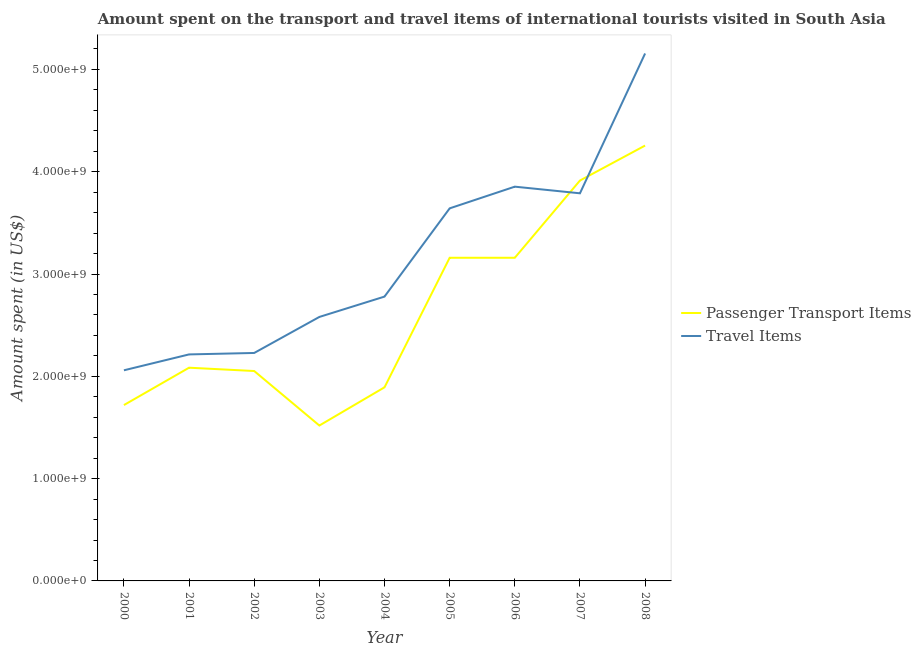Does the line corresponding to amount spent on passenger transport items intersect with the line corresponding to amount spent in travel items?
Make the answer very short. Yes. Is the number of lines equal to the number of legend labels?
Provide a short and direct response. Yes. What is the amount spent in travel items in 2008?
Provide a succinct answer. 5.16e+09. Across all years, what is the maximum amount spent in travel items?
Provide a succinct answer. 5.16e+09. Across all years, what is the minimum amount spent in travel items?
Offer a terse response. 2.06e+09. In which year was the amount spent in travel items minimum?
Keep it short and to the point. 2000. What is the total amount spent on passenger transport items in the graph?
Your answer should be very brief. 2.38e+1. What is the difference between the amount spent on passenger transport items in 2005 and that in 2008?
Offer a very short reply. -1.10e+09. What is the difference between the amount spent on passenger transport items in 2006 and the amount spent in travel items in 2008?
Ensure brevity in your answer.  -2.00e+09. What is the average amount spent in travel items per year?
Provide a succinct answer. 3.14e+09. In the year 2004, what is the difference between the amount spent in travel items and amount spent on passenger transport items?
Offer a terse response. 8.87e+08. In how many years, is the amount spent on passenger transport items greater than 1000000000 US$?
Give a very brief answer. 9. What is the ratio of the amount spent on passenger transport items in 2001 to that in 2006?
Ensure brevity in your answer.  0.66. What is the difference between the highest and the second highest amount spent in travel items?
Provide a succinct answer. 1.30e+09. What is the difference between the highest and the lowest amount spent on passenger transport items?
Provide a short and direct response. 2.74e+09. In how many years, is the amount spent on passenger transport items greater than the average amount spent on passenger transport items taken over all years?
Provide a succinct answer. 4. Is the sum of the amount spent on passenger transport items in 2001 and 2008 greater than the maximum amount spent in travel items across all years?
Provide a succinct answer. Yes. Is the amount spent on passenger transport items strictly greater than the amount spent in travel items over the years?
Ensure brevity in your answer.  No. How many lines are there?
Your answer should be compact. 2. Where does the legend appear in the graph?
Offer a terse response. Center right. What is the title of the graph?
Provide a short and direct response. Amount spent on the transport and travel items of international tourists visited in South Asia. What is the label or title of the X-axis?
Provide a short and direct response. Year. What is the label or title of the Y-axis?
Give a very brief answer. Amount spent (in US$). What is the Amount spent (in US$) in Passenger Transport Items in 2000?
Give a very brief answer. 1.72e+09. What is the Amount spent (in US$) of Travel Items in 2000?
Make the answer very short. 2.06e+09. What is the Amount spent (in US$) in Passenger Transport Items in 2001?
Give a very brief answer. 2.08e+09. What is the Amount spent (in US$) in Travel Items in 2001?
Make the answer very short. 2.21e+09. What is the Amount spent (in US$) of Passenger Transport Items in 2002?
Your response must be concise. 2.05e+09. What is the Amount spent (in US$) of Travel Items in 2002?
Your response must be concise. 2.23e+09. What is the Amount spent (in US$) of Passenger Transport Items in 2003?
Ensure brevity in your answer.  1.52e+09. What is the Amount spent (in US$) in Travel Items in 2003?
Make the answer very short. 2.58e+09. What is the Amount spent (in US$) in Passenger Transport Items in 2004?
Keep it short and to the point. 1.89e+09. What is the Amount spent (in US$) in Travel Items in 2004?
Offer a very short reply. 2.78e+09. What is the Amount spent (in US$) of Passenger Transport Items in 2005?
Provide a succinct answer. 3.16e+09. What is the Amount spent (in US$) in Travel Items in 2005?
Your answer should be compact. 3.64e+09. What is the Amount spent (in US$) of Passenger Transport Items in 2006?
Your answer should be compact. 3.16e+09. What is the Amount spent (in US$) in Travel Items in 2006?
Offer a terse response. 3.85e+09. What is the Amount spent (in US$) of Passenger Transport Items in 2007?
Provide a short and direct response. 3.91e+09. What is the Amount spent (in US$) of Travel Items in 2007?
Your answer should be compact. 3.79e+09. What is the Amount spent (in US$) of Passenger Transport Items in 2008?
Provide a short and direct response. 4.26e+09. What is the Amount spent (in US$) of Travel Items in 2008?
Your answer should be very brief. 5.16e+09. Across all years, what is the maximum Amount spent (in US$) in Passenger Transport Items?
Your answer should be very brief. 4.26e+09. Across all years, what is the maximum Amount spent (in US$) of Travel Items?
Ensure brevity in your answer.  5.16e+09. Across all years, what is the minimum Amount spent (in US$) of Passenger Transport Items?
Your response must be concise. 1.52e+09. Across all years, what is the minimum Amount spent (in US$) of Travel Items?
Ensure brevity in your answer.  2.06e+09. What is the total Amount spent (in US$) of Passenger Transport Items in the graph?
Make the answer very short. 2.38e+1. What is the total Amount spent (in US$) in Travel Items in the graph?
Keep it short and to the point. 2.83e+1. What is the difference between the Amount spent (in US$) of Passenger Transport Items in 2000 and that in 2001?
Offer a terse response. -3.65e+08. What is the difference between the Amount spent (in US$) of Travel Items in 2000 and that in 2001?
Your answer should be compact. -1.55e+08. What is the difference between the Amount spent (in US$) in Passenger Transport Items in 2000 and that in 2002?
Your answer should be very brief. -3.33e+08. What is the difference between the Amount spent (in US$) of Travel Items in 2000 and that in 2002?
Your answer should be compact. -1.69e+08. What is the difference between the Amount spent (in US$) in Passenger Transport Items in 2000 and that in 2003?
Your response must be concise. 2.00e+08. What is the difference between the Amount spent (in US$) of Travel Items in 2000 and that in 2003?
Ensure brevity in your answer.  -5.22e+08. What is the difference between the Amount spent (in US$) of Passenger Transport Items in 2000 and that in 2004?
Offer a very short reply. -1.74e+08. What is the difference between the Amount spent (in US$) of Travel Items in 2000 and that in 2004?
Provide a short and direct response. -7.20e+08. What is the difference between the Amount spent (in US$) of Passenger Transport Items in 2000 and that in 2005?
Provide a short and direct response. -1.44e+09. What is the difference between the Amount spent (in US$) of Travel Items in 2000 and that in 2005?
Give a very brief answer. -1.58e+09. What is the difference between the Amount spent (in US$) in Passenger Transport Items in 2000 and that in 2006?
Keep it short and to the point. -1.44e+09. What is the difference between the Amount spent (in US$) of Travel Items in 2000 and that in 2006?
Provide a succinct answer. -1.80e+09. What is the difference between the Amount spent (in US$) of Passenger Transport Items in 2000 and that in 2007?
Your response must be concise. -2.19e+09. What is the difference between the Amount spent (in US$) in Travel Items in 2000 and that in 2007?
Give a very brief answer. -1.73e+09. What is the difference between the Amount spent (in US$) in Passenger Transport Items in 2000 and that in 2008?
Your response must be concise. -2.54e+09. What is the difference between the Amount spent (in US$) of Travel Items in 2000 and that in 2008?
Make the answer very short. -3.10e+09. What is the difference between the Amount spent (in US$) in Passenger Transport Items in 2001 and that in 2002?
Provide a short and direct response. 3.25e+07. What is the difference between the Amount spent (in US$) in Travel Items in 2001 and that in 2002?
Your response must be concise. -1.42e+07. What is the difference between the Amount spent (in US$) in Passenger Transport Items in 2001 and that in 2003?
Give a very brief answer. 5.65e+08. What is the difference between the Amount spent (in US$) of Travel Items in 2001 and that in 2003?
Give a very brief answer. -3.66e+08. What is the difference between the Amount spent (in US$) in Passenger Transport Items in 2001 and that in 2004?
Make the answer very short. 1.92e+08. What is the difference between the Amount spent (in US$) in Travel Items in 2001 and that in 2004?
Ensure brevity in your answer.  -5.65e+08. What is the difference between the Amount spent (in US$) in Passenger Transport Items in 2001 and that in 2005?
Offer a terse response. -1.07e+09. What is the difference between the Amount spent (in US$) of Travel Items in 2001 and that in 2005?
Offer a very short reply. -1.43e+09. What is the difference between the Amount spent (in US$) of Passenger Transport Items in 2001 and that in 2006?
Make the answer very short. -1.07e+09. What is the difference between the Amount spent (in US$) in Travel Items in 2001 and that in 2006?
Offer a terse response. -1.64e+09. What is the difference between the Amount spent (in US$) of Passenger Transport Items in 2001 and that in 2007?
Ensure brevity in your answer.  -1.83e+09. What is the difference between the Amount spent (in US$) of Travel Items in 2001 and that in 2007?
Offer a terse response. -1.57e+09. What is the difference between the Amount spent (in US$) in Passenger Transport Items in 2001 and that in 2008?
Offer a terse response. -2.17e+09. What is the difference between the Amount spent (in US$) of Travel Items in 2001 and that in 2008?
Give a very brief answer. -2.94e+09. What is the difference between the Amount spent (in US$) of Passenger Transport Items in 2002 and that in 2003?
Your response must be concise. 5.33e+08. What is the difference between the Amount spent (in US$) in Travel Items in 2002 and that in 2003?
Your response must be concise. -3.52e+08. What is the difference between the Amount spent (in US$) in Passenger Transport Items in 2002 and that in 2004?
Your answer should be compact. 1.59e+08. What is the difference between the Amount spent (in US$) in Travel Items in 2002 and that in 2004?
Your answer should be compact. -5.51e+08. What is the difference between the Amount spent (in US$) in Passenger Transport Items in 2002 and that in 2005?
Your answer should be very brief. -1.11e+09. What is the difference between the Amount spent (in US$) in Travel Items in 2002 and that in 2005?
Ensure brevity in your answer.  -1.41e+09. What is the difference between the Amount spent (in US$) of Passenger Transport Items in 2002 and that in 2006?
Provide a short and direct response. -1.11e+09. What is the difference between the Amount spent (in US$) in Travel Items in 2002 and that in 2006?
Provide a succinct answer. -1.63e+09. What is the difference between the Amount spent (in US$) of Passenger Transport Items in 2002 and that in 2007?
Your response must be concise. -1.86e+09. What is the difference between the Amount spent (in US$) in Travel Items in 2002 and that in 2007?
Make the answer very short. -1.56e+09. What is the difference between the Amount spent (in US$) of Passenger Transport Items in 2002 and that in 2008?
Keep it short and to the point. -2.20e+09. What is the difference between the Amount spent (in US$) in Travel Items in 2002 and that in 2008?
Ensure brevity in your answer.  -2.93e+09. What is the difference between the Amount spent (in US$) in Passenger Transport Items in 2003 and that in 2004?
Provide a short and direct response. -3.73e+08. What is the difference between the Amount spent (in US$) in Travel Items in 2003 and that in 2004?
Keep it short and to the point. -1.99e+08. What is the difference between the Amount spent (in US$) in Passenger Transport Items in 2003 and that in 2005?
Keep it short and to the point. -1.64e+09. What is the difference between the Amount spent (in US$) of Travel Items in 2003 and that in 2005?
Offer a very short reply. -1.06e+09. What is the difference between the Amount spent (in US$) of Passenger Transport Items in 2003 and that in 2006?
Offer a terse response. -1.64e+09. What is the difference between the Amount spent (in US$) of Travel Items in 2003 and that in 2006?
Make the answer very short. -1.27e+09. What is the difference between the Amount spent (in US$) in Passenger Transport Items in 2003 and that in 2007?
Provide a succinct answer. -2.39e+09. What is the difference between the Amount spent (in US$) of Travel Items in 2003 and that in 2007?
Your response must be concise. -1.21e+09. What is the difference between the Amount spent (in US$) of Passenger Transport Items in 2003 and that in 2008?
Provide a succinct answer. -2.74e+09. What is the difference between the Amount spent (in US$) of Travel Items in 2003 and that in 2008?
Provide a succinct answer. -2.58e+09. What is the difference between the Amount spent (in US$) in Passenger Transport Items in 2004 and that in 2005?
Your answer should be very brief. -1.27e+09. What is the difference between the Amount spent (in US$) in Travel Items in 2004 and that in 2005?
Keep it short and to the point. -8.63e+08. What is the difference between the Amount spent (in US$) in Passenger Transport Items in 2004 and that in 2006?
Provide a succinct answer. -1.27e+09. What is the difference between the Amount spent (in US$) of Travel Items in 2004 and that in 2006?
Your answer should be very brief. -1.07e+09. What is the difference between the Amount spent (in US$) of Passenger Transport Items in 2004 and that in 2007?
Make the answer very short. -2.02e+09. What is the difference between the Amount spent (in US$) in Travel Items in 2004 and that in 2007?
Keep it short and to the point. -1.01e+09. What is the difference between the Amount spent (in US$) in Passenger Transport Items in 2004 and that in 2008?
Give a very brief answer. -2.36e+09. What is the difference between the Amount spent (in US$) of Travel Items in 2004 and that in 2008?
Ensure brevity in your answer.  -2.38e+09. What is the difference between the Amount spent (in US$) in Passenger Transport Items in 2005 and that in 2006?
Make the answer very short. 0. What is the difference between the Amount spent (in US$) in Travel Items in 2005 and that in 2006?
Offer a terse response. -2.12e+08. What is the difference between the Amount spent (in US$) in Passenger Transport Items in 2005 and that in 2007?
Provide a short and direct response. -7.55e+08. What is the difference between the Amount spent (in US$) of Travel Items in 2005 and that in 2007?
Provide a succinct answer. -1.47e+08. What is the difference between the Amount spent (in US$) in Passenger Transport Items in 2005 and that in 2008?
Your answer should be very brief. -1.10e+09. What is the difference between the Amount spent (in US$) of Travel Items in 2005 and that in 2008?
Your response must be concise. -1.51e+09. What is the difference between the Amount spent (in US$) of Passenger Transport Items in 2006 and that in 2007?
Give a very brief answer. -7.55e+08. What is the difference between the Amount spent (in US$) in Travel Items in 2006 and that in 2007?
Your response must be concise. 6.49e+07. What is the difference between the Amount spent (in US$) in Passenger Transport Items in 2006 and that in 2008?
Keep it short and to the point. -1.10e+09. What is the difference between the Amount spent (in US$) in Travel Items in 2006 and that in 2008?
Make the answer very short. -1.30e+09. What is the difference between the Amount spent (in US$) in Passenger Transport Items in 2007 and that in 2008?
Provide a short and direct response. -3.42e+08. What is the difference between the Amount spent (in US$) of Travel Items in 2007 and that in 2008?
Your answer should be compact. -1.37e+09. What is the difference between the Amount spent (in US$) of Passenger Transport Items in 2000 and the Amount spent (in US$) of Travel Items in 2001?
Your answer should be very brief. -4.95e+08. What is the difference between the Amount spent (in US$) in Passenger Transport Items in 2000 and the Amount spent (in US$) in Travel Items in 2002?
Keep it short and to the point. -5.09e+08. What is the difference between the Amount spent (in US$) in Passenger Transport Items in 2000 and the Amount spent (in US$) in Travel Items in 2003?
Offer a terse response. -8.62e+08. What is the difference between the Amount spent (in US$) in Passenger Transport Items in 2000 and the Amount spent (in US$) in Travel Items in 2004?
Offer a terse response. -1.06e+09. What is the difference between the Amount spent (in US$) of Passenger Transport Items in 2000 and the Amount spent (in US$) of Travel Items in 2005?
Make the answer very short. -1.92e+09. What is the difference between the Amount spent (in US$) of Passenger Transport Items in 2000 and the Amount spent (in US$) of Travel Items in 2006?
Your answer should be very brief. -2.13e+09. What is the difference between the Amount spent (in US$) in Passenger Transport Items in 2000 and the Amount spent (in US$) in Travel Items in 2007?
Make the answer very short. -2.07e+09. What is the difference between the Amount spent (in US$) of Passenger Transport Items in 2000 and the Amount spent (in US$) of Travel Items in 2008?
Provide a short and direct response. -3.44e+09. What is the difference between the Amount spent (in US$) in Passenger Transport Items in 2001 and the Amount spent (in US$) in Travel Items in 2002?
Ensure brevity in your answer.  -1.44e+08. What is the difference between the Amount spent (in US$) in Passenger Transport Items in 2001 and the Amount spent (in US$) in Travel Items in 2003?
Ensure brevity in your answer.  -4.96e+08. What is the difference between the Amount spent (in US$) in Passenger Transport Items in 2001 and the Amount spent (in US$) in Travel Items in 2004?
Provide a short and direct response. -6.95e+08. What is the difference between the Amount spent (in US$) of Passenger Transport Items in 2001 and the Amount spent (in US$) of Travel Items in 2005?
Keep it short and to the point. -1.56e+09. What is the difference between the Amount spent (in US$) in Passenger Transport Items in 2001 and the Amount spent (in US$) in Travel Items in 2006?
Your response must be concise. -1.77e+09. What is the difference between the Amount spent (in US$) of Passenger Transport Items in 2001 and the Amount spent (in US$) of Travel Items in 2007?
Your response must be concise. -1.70e+09. What is the difference between the Amount spent (in US$) of Passenger Transport Items in 2001 and the Amount spent (in US$) of Travel Items in 2008?
Your answer should be compact. -3.07e+09. What is the difference between the Amount spent (in US$) of Passenger Transport Items in 2002 and the Amount spent (in US$) of Travel Items in 2003?
Offer a terse response. -5.29e+08. What is the difference between the Amount spent (in US$) of Passenger Transport Items in 2002 and the Amount spent (in US$) of Travel Items in 2004?
Your answer should be very brief. -7.28e+08. What is the difference between the Amount spent (in US$) of Passenger Transport Items in 2002 and the Amount spent (in US$) of Travel Items in 2005?
Ensure brevity in your answer.  -1.59e+09. What is the difference between the Amount spent (in US$) of Passenger Transport Items in 2002 and the Amount spent (in US$) of Travel Items in 2006?
Keep it short and to the point. -1.80e+09. What is the difference between the Amount spent (in US$) of Passenger Transport Items in 2002 and the Amount spent (in US$) of Travel Items in 2007?
Your answer should be very brief. -1.74e+09. What is the difference between the Amount spent (in US$) of Passenger Transport Items in 2002 and the Amount spent (in US$) of Travel Items in 2008?
Provide a succinct answer. -3.10e+09. What is the difference between the Amount spent (in US$) in Passenger Transport Items in 2003 and the Amount spent (in US$) in Travel Items in 2004?
Keep it short and to the point. -1.26e+09. What is the difference between the Amount spent (in US$) of Passenger Transport Items in 2003 and the Amount spent (in US$) of Travel Items in 2005?
Give a very brief answer. -2.12e+09. What is the difference between the Amount spent (in US$) in Passenger Transport Items in 2003 and the Amount spent (in US$) in Travel Items in 2006?
Your response must be concise. -2.33e+09. What is the difference between the Amount spent (in US$) in Passenger Transport Items in 2003 and the Amount spent (in US$) in Travel Items in 2007?
Ensure brevity in your answer.  -2.27e+09. What is the difference between the Amount spent (in US$) in Passenger Transport Items in 2003 and the Amount spent (in US$) in Travel Items in 2008?
Your answer should be compact. -3.64e+09. What is the difference between the Amount spent (in US$) in Passenger Transport Items in 2004 and the Amount spent (in US$) in Travel Items in 2005?
Your answer should be very brief. -1.75e+09. What is the difference between the Amount spent (in US$) of Passenger Transport Items in 2004 and the Amount spent (in US$) of Travel Items in 2006?
Your response must be concise. -1.96e+09. What is the difference between the Amount spent (in US$) in Passenger Transport Items in 2004 and the Amount spent (in US$) in Travel Items in 2007?
Keep it short and to the point. -1.90e+09. What is the difference between the Amount spent (in US$) of Passenger Transport Items in 2004 and the Amount spent (in US$) of Travel Items in 2008?
Offer a very short reply. -3.26e+09. What is the difference between the Amount spent (in US$) in Passenger Transport Items in 2005 and the Amount spent (in US$) in Travel Items in 2006?
Provide a succinct answer. -6.95e+08. What is the difference between the Amount spent (in US$) in Passenger Transport Items in 2005 and the Amount spent (in US$) in Travel Items in 2007?
Make the answer very short. -6.30e+08. What is the difference between the Amount spent (in US$) in Passenger Transport Items in 2005 and the Amount spent (in US$) in Travel Items in 2008?
Your answer should be very brief. -2.00e+09. What is the difference between the Amount spent (in US$) in Passenger Transport Items in 2006 and the Amount spent (in US$) in Travel Items in 2007?
Keep it short and to the point. -6.30e+08. What is the difference between the Amount spent (in US$) of Passenger Transport Items in 2006 and the Amount spent (in US$) of Travel Items in 2008?
Keep it short and to the point. -2.00e+09. What is the difference between the Amount spent (in US$) in Passenger Transport Items in 2007 and the Amount spent (in US$) in Travel Items in 2008?
Provide a succinct answer. -1.24e+09. What is the average Amount spent (in US$) of Passenger Transport Items per year?
Offer a terse response. 2.64e+09. What is the average Amount spent (in US$) of Travel Items per year?
Offer a terse response. 3.14e+09. In the year 2000, what is the difference between the Amount spent (in US$) of Passenger Transport Items and Amount spent (in US$) of Travel Items?
Make the answer very short. -3.40e+08. In the year 2001, what is the difference between the Amount spent (in US$) of Passenger Transport Items and Amount spent (in US$) of Travel Items?
Your answer should be compact. -1.30e+08. In the year 2002, what is the difference between the Amount spent (in US$) of Passenger Transport Items and Amount spent (in US$) of Travel Items?
Give a very brief answer. -1.77e+08. In the year 2003, what is the difference between the Amount spent (in US$) of Passenger Transport Items and Amount spent (in US$) of Travel Items?
Your answer should be compact. -1.06e+09. In the year 2004, what is the difference between the Amount spent (in US$) of Passenger Transport Items and Amount spent (in US$) of Travel Items?
Offer a very short reply. -8.87e+08. In the year 2005, what is the difference between the Amount spent (in US$) of Passenger Transport Items and Amount spent (in US$) of Travel Items?
Offer a terse response. -4.83e+08. In the year 2006, what is the difference between the Amount spent (in US$) in Passenger Transport Items and Amount spent (in US$) in Travel Items?
Give a very brief answer. -6.95e+08. In the year 2007, what is the difference between the Amount spent (in US$) of Passenger Transport Items and Amount spent (in US$) of Travel Items?
Provide a short and direct response. 1.25e+08. In the year 2008, what is the difference between the Amount spent (in US$) of Passenger Transport Items and Amount spent (in US$) of Travel Items?
Your answer should be very brief. -9.00e+08. What is the ratio of the Amount spent (in US$) in Passenger Transport Items in 2000 to that in 2001?
Your response must be concise. 0.82. What is the ratio of the Amount spent (in US$) in Travel Items in 2000 to that in 2001?
Make the answer very short. 0.93. What is the ratio of the Amount spent (in US$) of Passenger Transport Items in 2000 to that in 2002?
Your answer should be compact. 0.84. What is the ratio of the Amount spent (in US$) in Travel Items in 2000 to that in 2002?
Ensure brevity in your answer.  0.92. What is the ratio of the Amount spent (in US$) of Passenger Transport Items in 2000 to that in 2003?
Keep it short and to the point. 1.13. What is the ratio of the Amount spent (in US$) of Travel Items in 2000 to that in 2003?
Your answer should be very brief. 0.8. What is the ratio of the Amount spent (in US$) of Passenger Transport Items in 2000 to that in 2004?
Your response must be concise. 0.91. What is the ratio of the Amount spent (in US$) in Travel Items in 2000 to that in 2004?
Your response must be concise. 0.74. What is the ratio of the Amount spent (in US$) of Passenger Transport Items in 2000 to that in 2005?
Your answer should be very brief. 0.54. What is the ratio of the Amount spent (in US$) in Travel Items in 2000 to that in 2005?
Your answer should be compact. 0.57. What is the ratio of the Amount spent (in US$) of Passenger Transport Items in 2000 to that in 2006?
Make the answer very short. 0.54. What is the ratio of the Amount spent (in US$) of Travel Items in 2000 to that in 2006?
Make the answer very short. 0.53. What is the ratio of the Amount spent (in US$) in Passenger Transport Items in 2000 to that in 2007?
Offer a very short reply. 0.44. What is the ratio of the Amount spent (in US$) of Travel Items in 2000 to that in 2007?
Provide a succinct answer. 0.54. What is the ratio of the Amount spent (in US$) in Passenger Transport Items in 2000 to that in 2008?
Keep it short and to the point. 0.4. What is the ratio of the Amount spent (in US$) of Travel Items in 2000 to that in 2008?
Your response must be concise. 0.4. What is the ratio of the Amount spent (in US$) of Passenger Transport Items in 2001 to that in 2002?
Provide a succinct answer. 1.02. What is the ratio of the Amount spent (in US$) of Passenger Transport Items in 2001 to that in 2003?
Your answer should be compact. 1.37. What is the ratio of the Amount spent (in US$) of Travel Items in 2001 to that in 2003?
Ensure brevity in your answer.  0.86. What is the ratio of the Amount spent (in US$) in Passenger Transport Items in 2001 to that in 2004?
Your answer should be very brief. 1.1. What is the ratio of the Amount spent (in US$) of Travel Items in 2001 to that in 2004?
Ensure brevity in your answer.  0.8. What is the ratio of the Amount spent (in US$) in Passenger Transport Items in 2001 to that in 2005?
Provide a succinct answer. 0.66. What is the ratio of the Amount spent (in US$) of Travel Items in 2001 to that in 2005?
Your answer should be very brief. 0.61. What is the ratio of the Amount spent (in US$) in Passenger Transport Items in 2001 to that in 2006?
Offer a very short reply. 0.66. What is the ratio of the Amount spent (in US$) in Travel Items in 2001 to that in 2006?
Offer a terse response. 0.57. What is the ratio of the Amount spent (in US$) of Passenger Transport Items in 2001 to that in 2007?
Make the answer very short. 0.53. What is the ratio of the Amount spent (in US$) of Travel Items in 2001 to that in 2007?
Your answer should be compact. 0.58. What is the ratio of the Amount spent (in US$) of Passenger Transport Items in 2001 to that in 2008?
Give a very brief answer. 0.49. What is the ratio of the Amount spent (in US$) in Travel Items in 2001 to that in 2008?
Provide a succinct answer. 0.43. What is the ratio of the Amount spent (in US$) in Passenger Transport Items in 2002 to that in 2003?
Make the answer very short. 1.35. What is the ratio of the Amount spent (in US$) of Travel Items in 2002 to that in 2003?
Offer a terse response. 0.86. What is the ratio of the Amount spent (in US$) in Passenger Transport Items in 2002 to that in 2004?
Offer a terse response. 1.08. What is the ratio of the Amount spent (in US$) of Travel Items in 2002 to that in 2004?
Your response must be concise. 0.8. What is the ratio of the Amount spent (in US$) in Passenger Transport Items in 2002 to that in 2005?
Ensure brevity in your answer.  0.65. What is the ratio of the Amount spent (in US$) in Travel Items in 2002 to that in 2005?
Your response must be concise. 0.61. What is the ratio of the Amount spent (in US$) in Passenger Transport Items in 2002 to that in 2006?
Offer a very short reply. 0.65. What is the ratio of the Amount spent (in US$) of Travel Items in 2002 to that in 2006?
Provide a short and direct response. 0.58. What is the ratio of the Amount spent (in US$) in Passenger Transport Items in 2002 to that in 2007?
Your response must be concise. 0.52. What is the ratio of the Amount spent (in US$) in Travel Items in 2002 to that in 2007?
Keep it short and to the point. 0.59. What is the ratio of the Amount spent (in US$) in Passenger Transport Items in 2002 to that in 2008?
Offer a terse response. 0.48. What is the ratio of the Amount spent (in US$) in Travel Items in 2002 to that in 2008?
Make the answer very short. 0.43. What is the ratio of the Amount spent (in US$) in Passenger Transport Items in 2003 to that in 2004?
Make the answer very short. 0.8. What is the ratio of the Amount spent (in US$) of Travel Items in 2003 to that in 2004?
Offer a very short reply. 0.93. What is the ratio of the Amount spent (in US$) of Passenger Transport Items in 2003 to that in 2005?
Give a very brief answer. 0.48. What is the ratio of the Amount spent (in US$) in Travel Items in 2003 to that in 2005?
Provide a succinct answer. 0.71. What is the ratio of the Amount spent (in US$) of Passenger Transport Items in 2003 to that in 2006?
Provide a succinct answer. 0.48. What is the ratio of the Amount spent (in US$) in Travel Items in 2003 to that in 2006?
Your answer should be compact. 0.67. What is the ratio of the Amount spent (in US$) of Passenger Transport Items in 2003 to that in 2007?
Make the answer very short. 0.39. What is the ratio of the Amount spent (in US$) in Travel Items in 2003 to that in 2007?
Your answer should be very brief. 0.68. What is the ratio of the Amount spent (in US$) in Passenger Transport Items in 2003 to that in 2008?
Provide a short and direct response. 0.36. What is the ratio of the Amount spent (in US$) in Travel Items in 2003 to that in 2008?
Provide a short and direct response. 0.5. What is the ratio of the Amount spent (in US$) of Passenger Transport Items in 2004 to that in 2005?
Offer a very short reply. 0.6. What is the ratio of the Amount spent (in US$) in Travel Items in 2004 to that in 2005?
Your answer should be compact. 0.76. What is the ratio of the Amount spent (in US$) in Passenger Transport Items in 2004 to that in 2006?
Keep it short and to the point. 0.6. What is the ratio of the Amount spent (in US$) in Travel Items in 2004 to that in 2006?
Provide a succinct answer. 0.72. What is the ratio of the Amount spent (in US$) in Passenger Transport Items in 2004 to that in 2007?
Offer a very short reply. 0.48. What is the ratio of the Amount spent (in US$) in Travel Items in 2004 to that in 2007?
Provide a short and direct response. 0.73. What is the ratio of the Amount spent (in US$) of Passenger Transport Items in 2004 to that in 2008?
Give a very brief answer. 0.44. What is the ratio of the Amount spent (in US$) in Travel Items in 2004 to that in 2008?
Give a very brief answer. 0.54. What is the ratio of the Amount spent (in US$) of Travel Items in 2005 to that in 2006?
Your answer should be very brief. 0.94. What is the ratio of the Amount spent (in US$) of Passenger Transport Items in 2005 to that in 2007?
Your answer should be compact. 0.81. What is the ratio of the Amount spent (in US$) in Travel Items in 2005 to that in 2007?
Provide a short and direct response. 0.96. What is the ratio of the Amount spent (in US$) of Passenger Transport Items in 2005 to that in 2008?
Provide a succinct answer. 0.74. What is the ratio of the Amount spent (in US$) of Travel Items in 2005 to that in 2008?
Ensure brevity in your answer.  0.71. What is the ratio of the Amount spent (in US$) in Passenger Transport Items in 2006 to that in 2007?
Make the answer very short. 0.81. What is the ratio of the Amount spent (in US$) of Travel Items in 2006 to that in 2007?
Offer a terse response. 1.02. What is the ratio of the Amount spent (in US$) of Passenger Transport Items in 2006 to that in 2008?
Your answer should be compact. 0.74. What is the ratio of the Amount spent (in US$) in Travel Items in 2006 to that in 2008?
Your answer should be very brief. 0.75. What is the ratio of the Amount spent (in US$) of Passenger Transport Items in 2007 to that in 2008?
Ensure brevity in your answer.  0.92. What is the ratio of the Amount spent (in US$) in Travel Items in 2007 to that in 2008?
Offer a very short reply. 0.73. What is the difference between the highest and the second highest Amount spent (in US$) in Passenger Transport Items?
Your answer should be compact. 3.42e+08. What is the difference between the highest and the second highest Amount spent (in US$) in Travel Items?
Provide a short and direct response. 1.30e+09. What is the difference between the highest and the lowest Amount spent (in US$) in Passenger Transport Items?
Provide a short and direct response. 2.74e+09. What is the difference between the highest and the lowest Amount spent (in US$) in Travel Items?
Ensure brevity in your answer.  3.10e+09. 